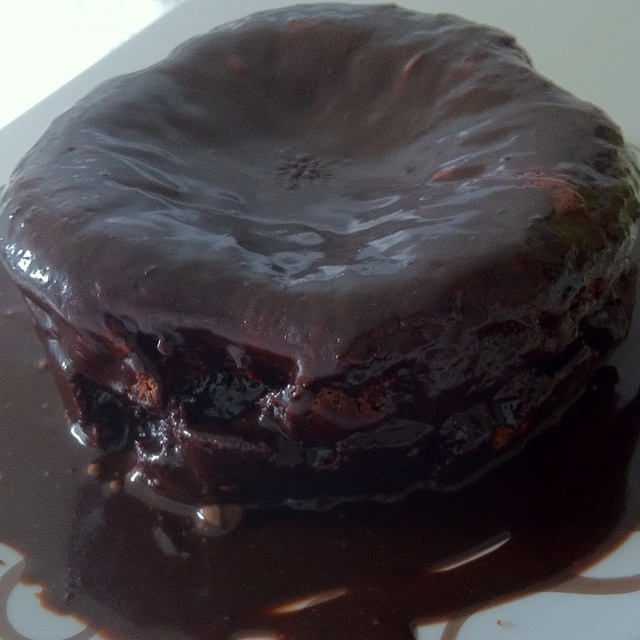Describe the objects in this image and their specific colors. I can see a cake in black, ivory, and gray tones in this image. 